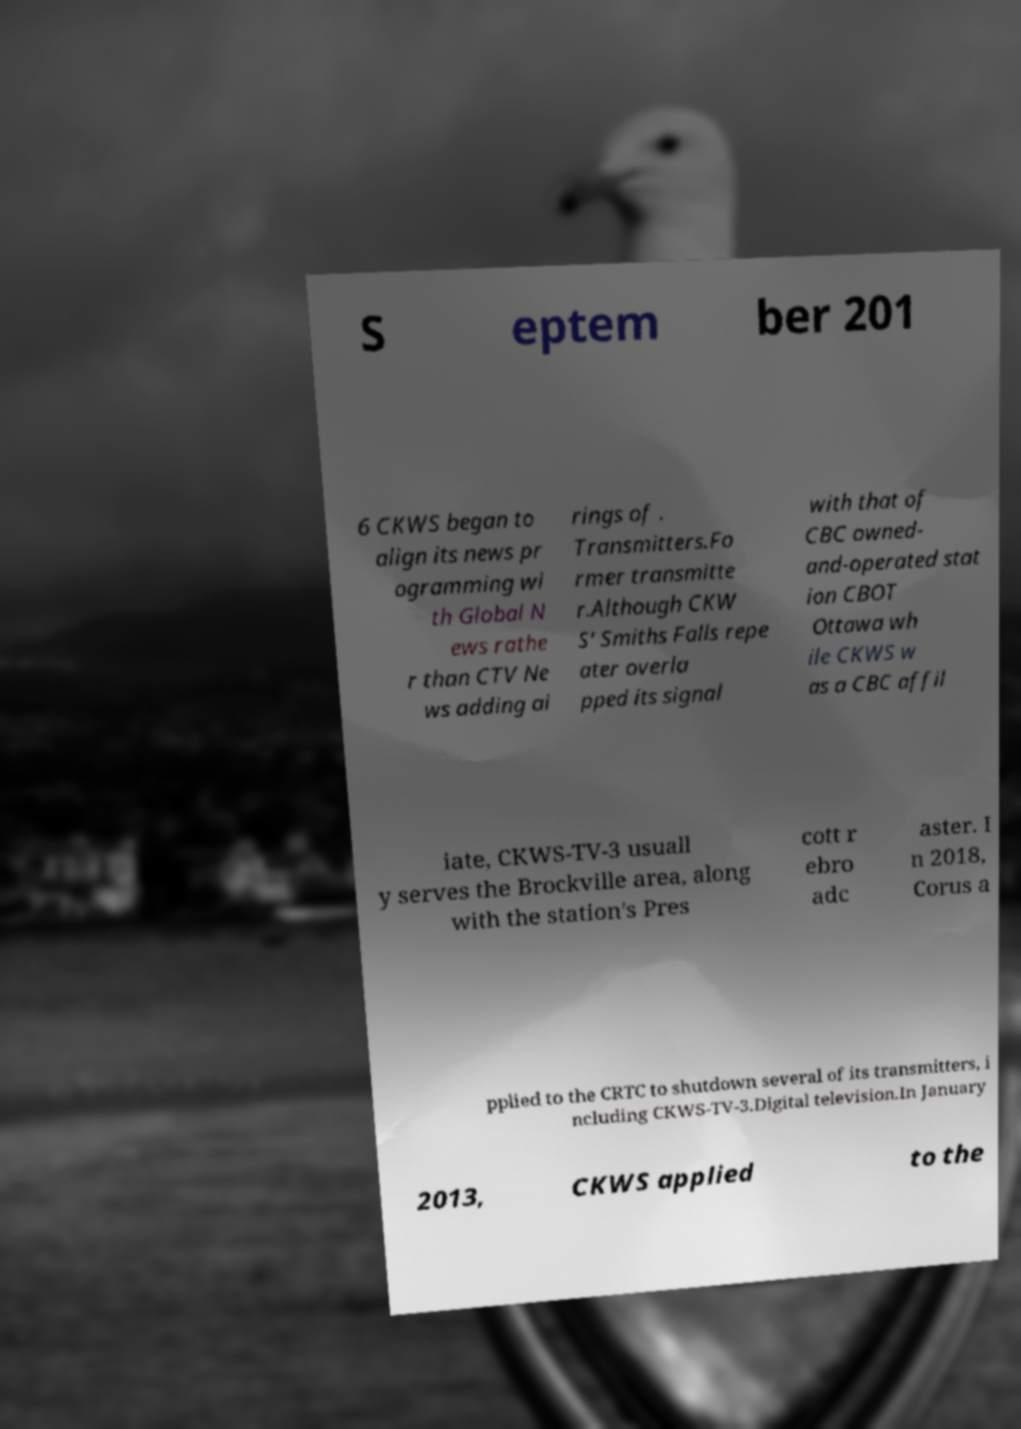What messages or text are displayed in this image? I need them in a readable, typed format. S eptem ber 201 6 CKWS began to align its news pr ogramming wi th Global N ews rathe r than CTV Ne ws adding ai rings of . Transmitters.Fo rmer transmitte r.Although CKW S' Smiths Falls repe ater overla pped its signal with that of CBC owned- and-operated stat ion CBOT Ottawa wh ile CKWS w as a CBC affil iate, CKWS-TV-3 usuall y serves the Brockville area, along with the station's Pres cott r ebro adc aster. I n 2018, Corus a pplied to the CRTC to shutdown several of its transmitters, i ncluding CKWS-TV-3.Digital television.In January 2013, CKWS applied to the 